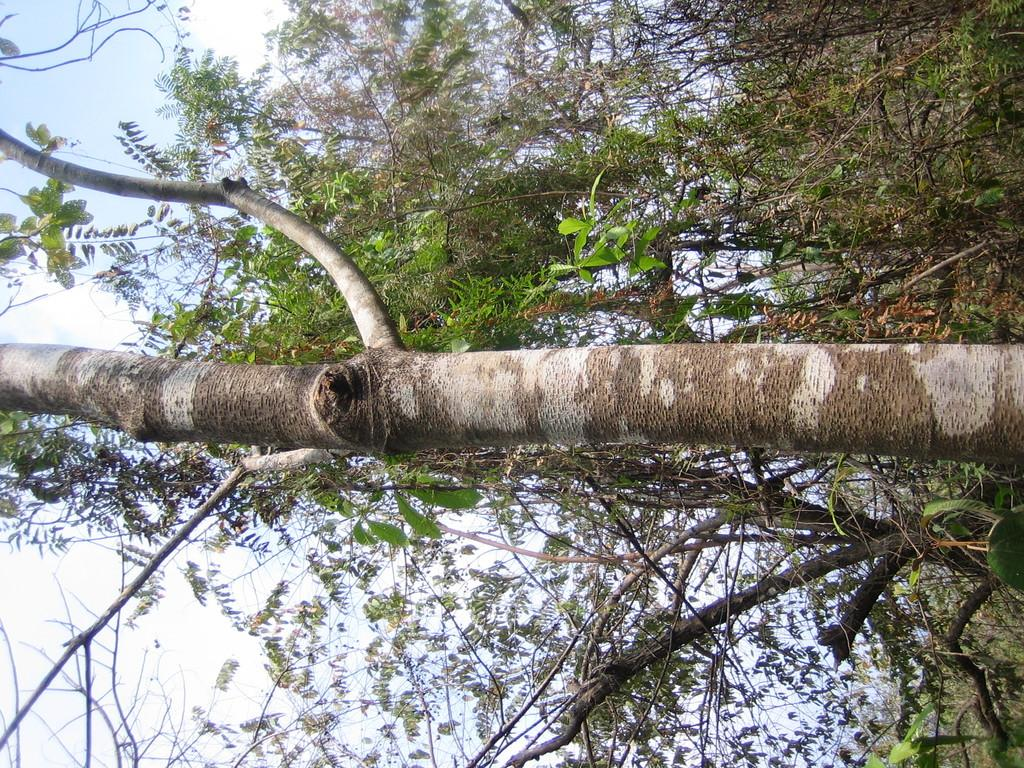What type of vegetation can be seen in the image? There are trees in the image. What part of the natural environment is visible in the image? The sky is visible in the background of the image. What is the girl attempting to paint on the canvas in the image? There is no girl or canvas present in the image; it only features trees and the sky. 